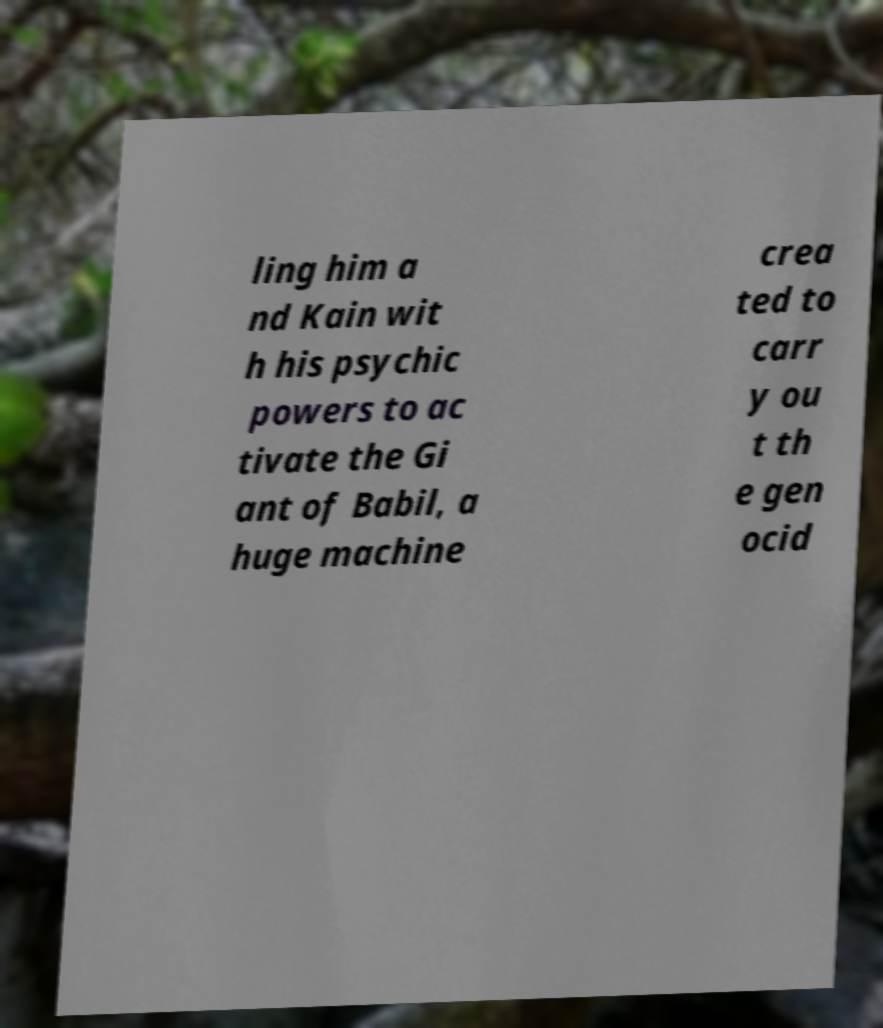Could you extract and type out the text from this image? ling him a nd Kain wit h his psychic powers to ac tivate the Gi ant of Babil, a huge machine crea ted to carr y ou t th e gen ocid 